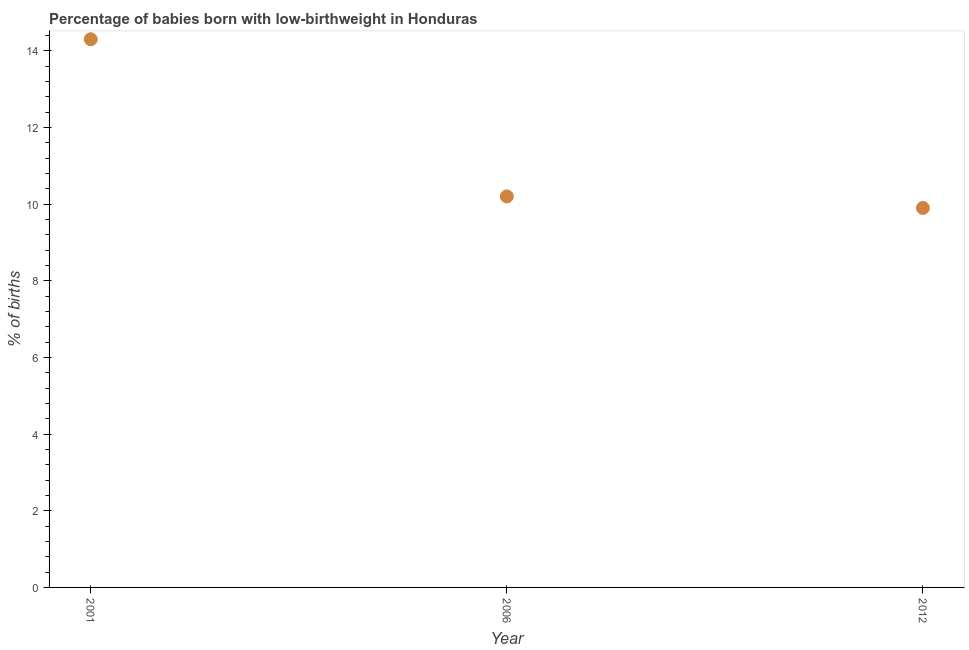What is the sum of the percentage of babies who were born with low-birthweight?
Your answer should be compact. 34.4. What is the difference between the percentage of babies who were born with low-birthweight in 2006 and 2012?
Offer a very short reply. 0.3. What is the average percentage of babies who were born with low-birthweight per year?
Your answer should be compact. 11.47. In how many years, is the percentage of babies who were born with low-birthweight greater than 12.8 %?
Your answer should be compact. 1. Do a majority of the years between 2001 and 2012 (inclusive) have percentage of babies who were born with low-birthweight greater than 2.4 %?
Provide a short and direct response. Yes. What is the ratio of the percentage of babies who were born with low-birthweight in 2006 to that in 2012?
Provide a short and direct response. 1.03. Is the percentage of babies who were born with low-birthweight in 2006 less than that in 2012?
Provide a short and direct response. No. Is the difference between the percentage of babies who were born with low-birthweight in 2001 and 2012 greater than the difference between any two years?
Make the answer very short. Yes. What is the difference between the highest and the second highest percentage of babies who were born with low-birthweight?
Give a very brief answer. 4.1. Is the sum of the percentage of babies who were born with low-birthweight in 2001 and 2012 greater than the maximum percentage of babies who were born with low-birthweight across all years?
Offer a very short reply. Yes. Does the percentage of babies who were born with low-birthweight monotonically increase over the years?
Offer a very short reply. No. What is the difference between two consecutive major ticks on the Y-axis?
Ensure brevity in your answer.  2. Are the values on the major ticks of Y-axis written in scientific E-notation?
Ensure brevity in your answer.  No. Does the graph contain any zero values?
Give a very brief answer. No. Does the graph contain grids?
Make the answer very short. No. What is the title of the graph?
Provide a succinct answer. Percentage of babies born with low-birthweight in Honduras. What is the label or title of the X-axis?
Your response must be concise. Year. What is the label or title of the Y-axis?
Provide a short and direct response. % of births. What is the % of births in 2001?
Offer a very short reply. 14.3. What is the % of births in 2006?
Your response must be concise. 10.2. What is the % of births in 2012?
Offer a terse response. 9.9. What is the difference between the % of births in 2006 and 2012?
Your answer should be compact. 0.3. What is the ratio of the % of births in 2001 to that in 2006?
Keep it short and to the point. 1.4. What is the ratio of the % of births in 2001 to that in 2012?
Your answer should be very brief. 1.44. What is the ratio of the % of births in 2006 to that in 2012?
Provide a succinct answer. 1.03. 